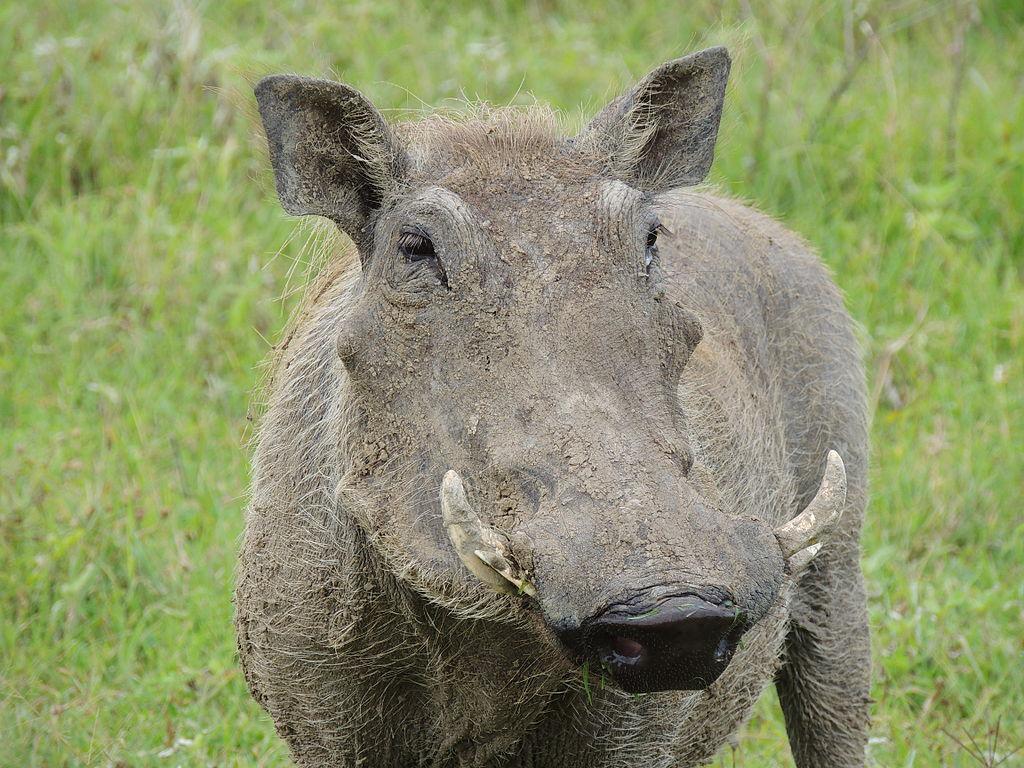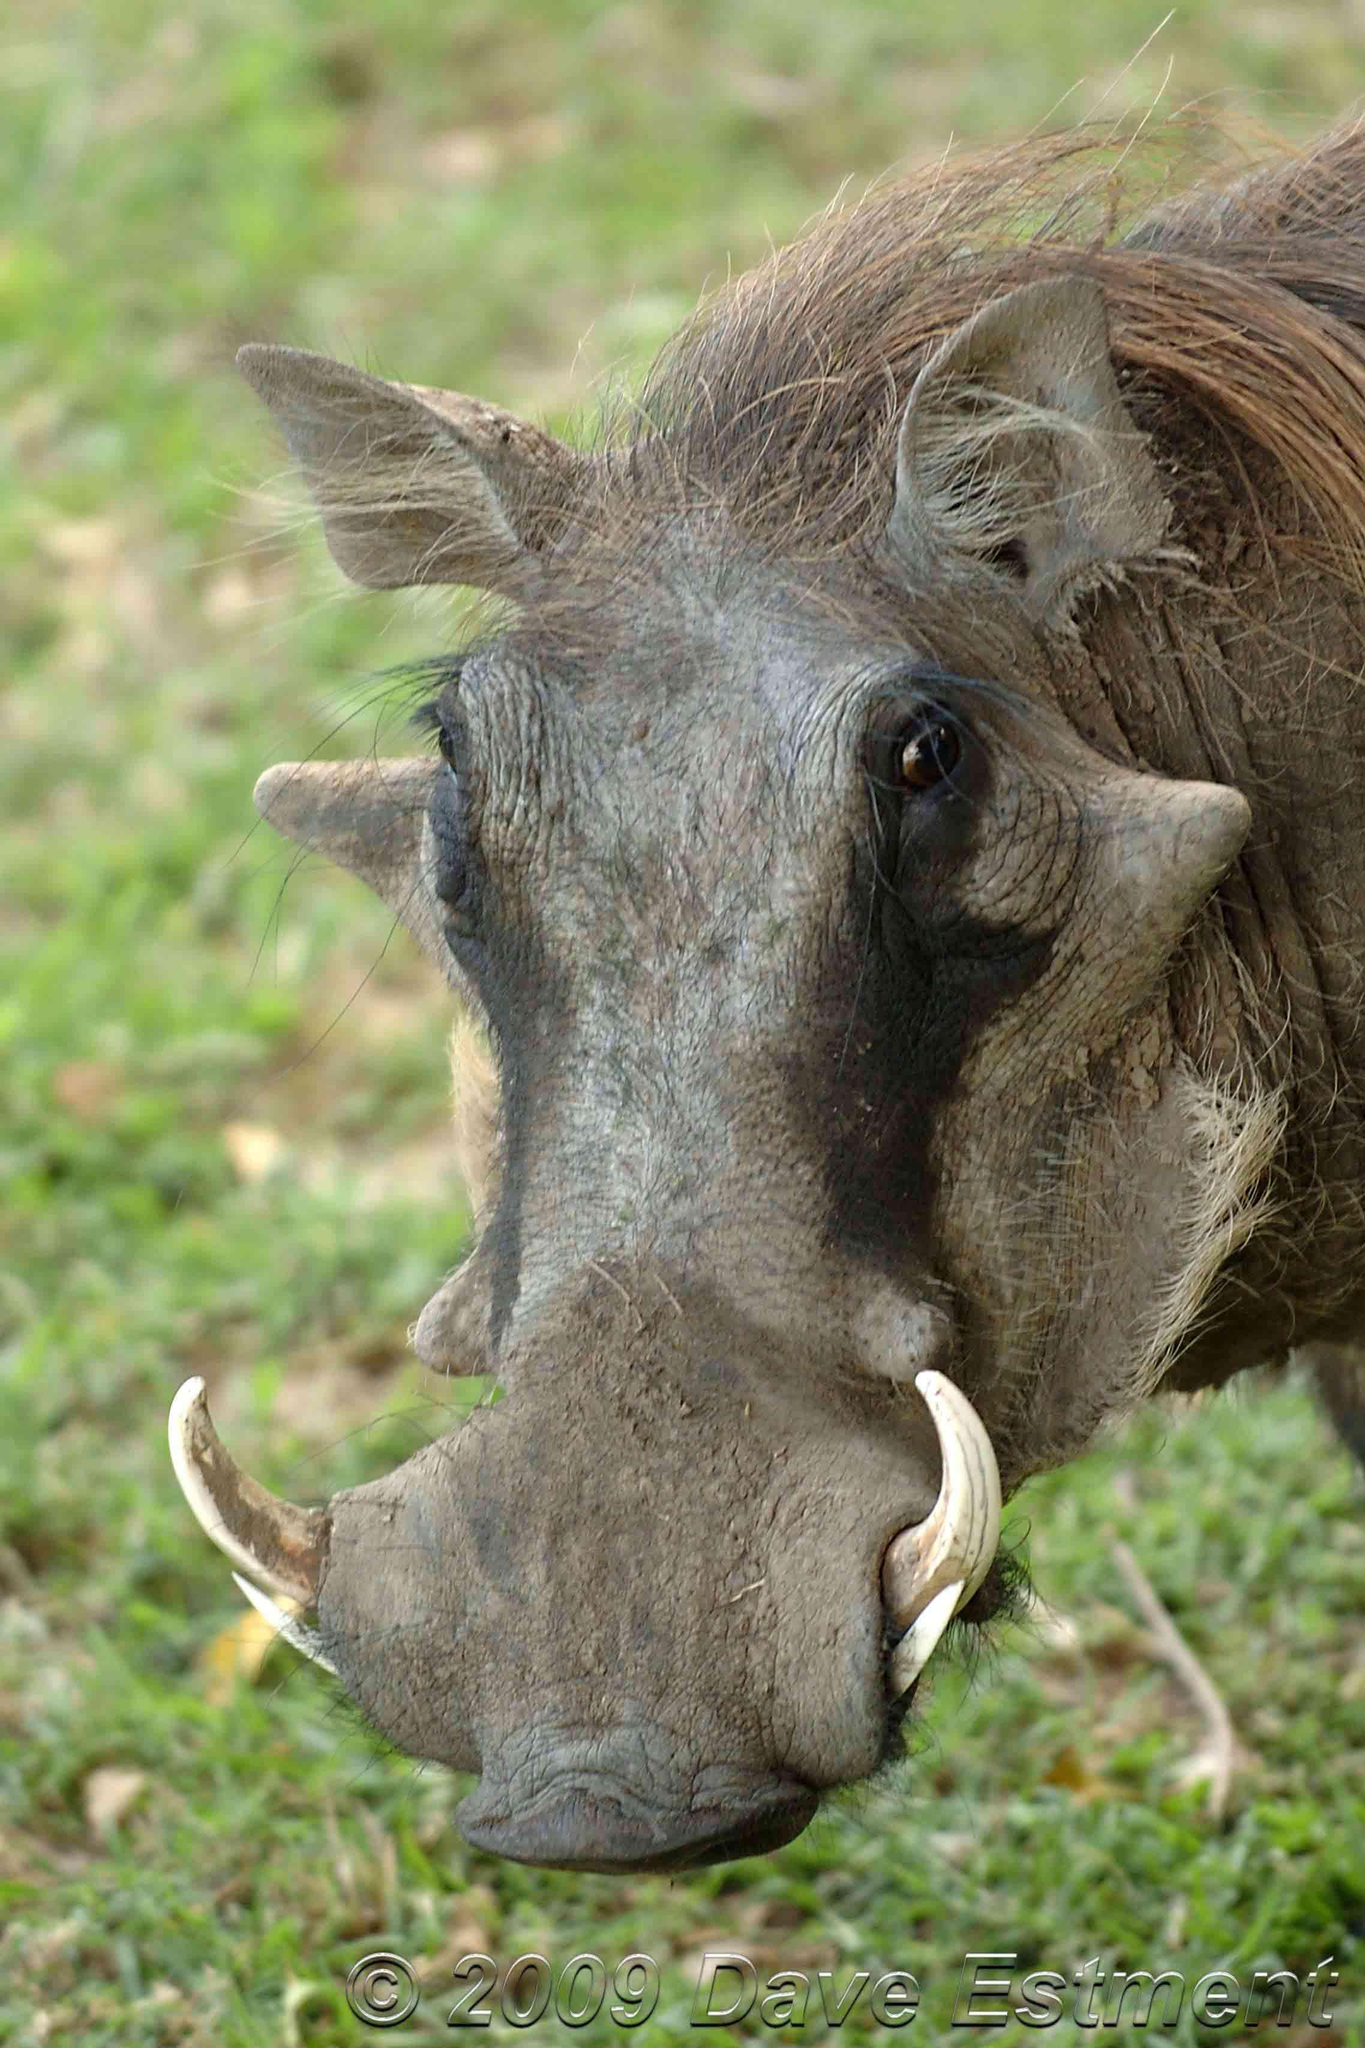The first image is the image on the left, the second image is the image on the right. Evaluate the accuracy of this statement regarding the images: "At least one image contains more than one warthog.". Is it true? Answer yes or no. No. 